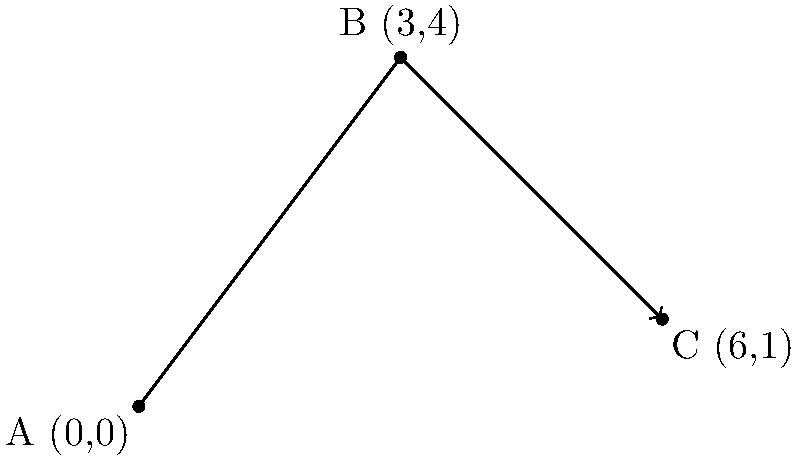During a special procession, three altar servers are positioned on a coordinate plane representing the church floor. Server A is at the origin (0,0), Server B is at (3,4), and Server C is at (6,1). What is the total distance traveled by a priest walking from Server A to Server B, then to Server C? To solve this problem, we need to calculate the distances between the servers and then add them together. We can use the distance formula to find the length of each segment.

1. Distance from A to B:
   $d_{AB} = \sqrt{(x_2-x_1)^2 + (y_2-y_1)^2}$
   $d_{AB} = \sqrt{(3-0)^2 + (4-0)^2} = \sqrt{9 + 16} = \sqrt{25} = 5$

2. Distance from B to C:
   $d_{BC} = \sqrt{(x_3-x_2)^2 + (y_3-y_2)^2}$
   $d_{BC} = \sqrt{(6-3)^2 + (1-4)^2} = \sqrt{9 + (-3)^2} = \sqrt{18} = 3\sqrt{2}$

3. Total distance:
   $d_{total} = d_{AB} + d_{BC} = 5 + 3\sqrt{2}$

Therefore, the total distance traveled by the priest is $5 + 3\sqrt{2}$ units.
Answer: $5 + 3\sqrt{2}$ units 